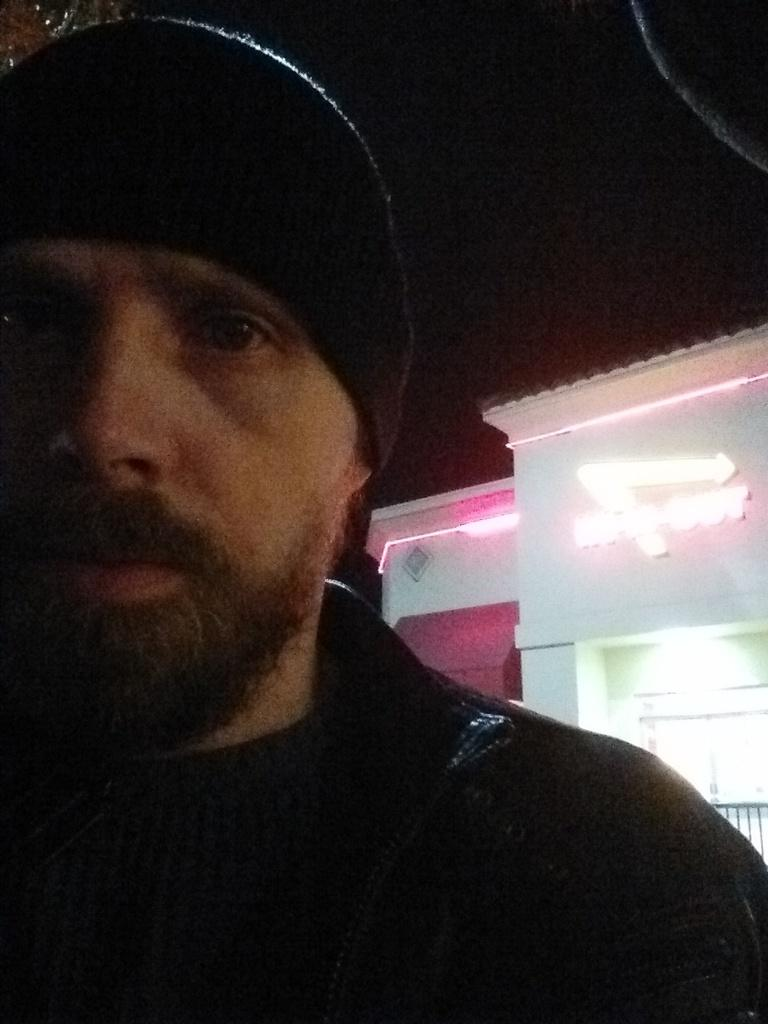Who or what is present in the image? There is a person in the image. What can be seen in the background of the image? There is a building with lights in the background of the image. How would you describe the sky in the background of the image? The sky is dark in the background of the image. What type of sheet is covering the downtown station in the image? There is no sheet, downtown, or station present in the image. 